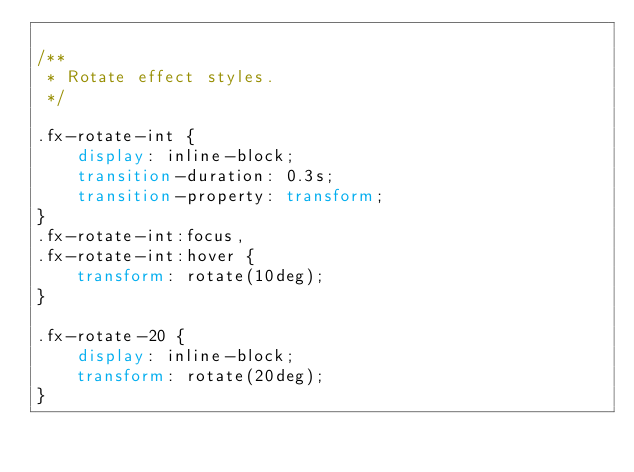<code> <loc_0><loc_0><loc_500><loc_500><_CSS_>
/**
 * Rotate effect styles.
 */

.fx-rotate-int {
	display: inline-block;
	transition-duration: 0.3s;
	transition-property: transform;
}
.fx-rotate-int:focus,
.fx-rotate-int:hover {
	transform: rotate(10deg);
}

.fx-rotate-20 {
	display: inline-block;
	transform: rotate(20deg);
}
</code> 